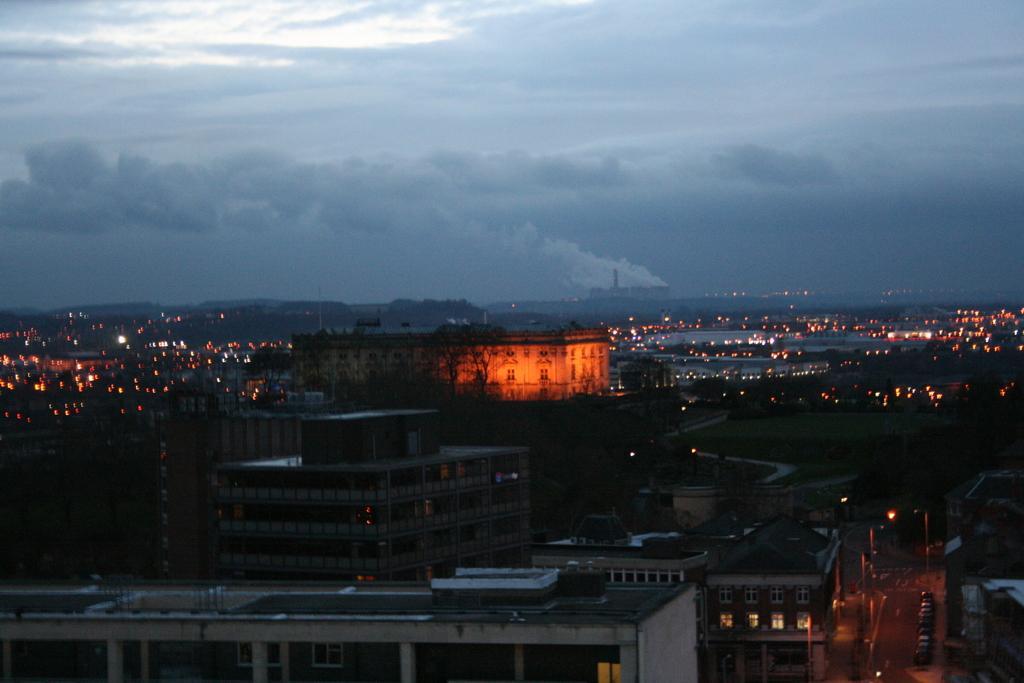Could you give a brief overview of what you see in this image? In the picture I can see buildings, lights and the cloudy sky in the background. 